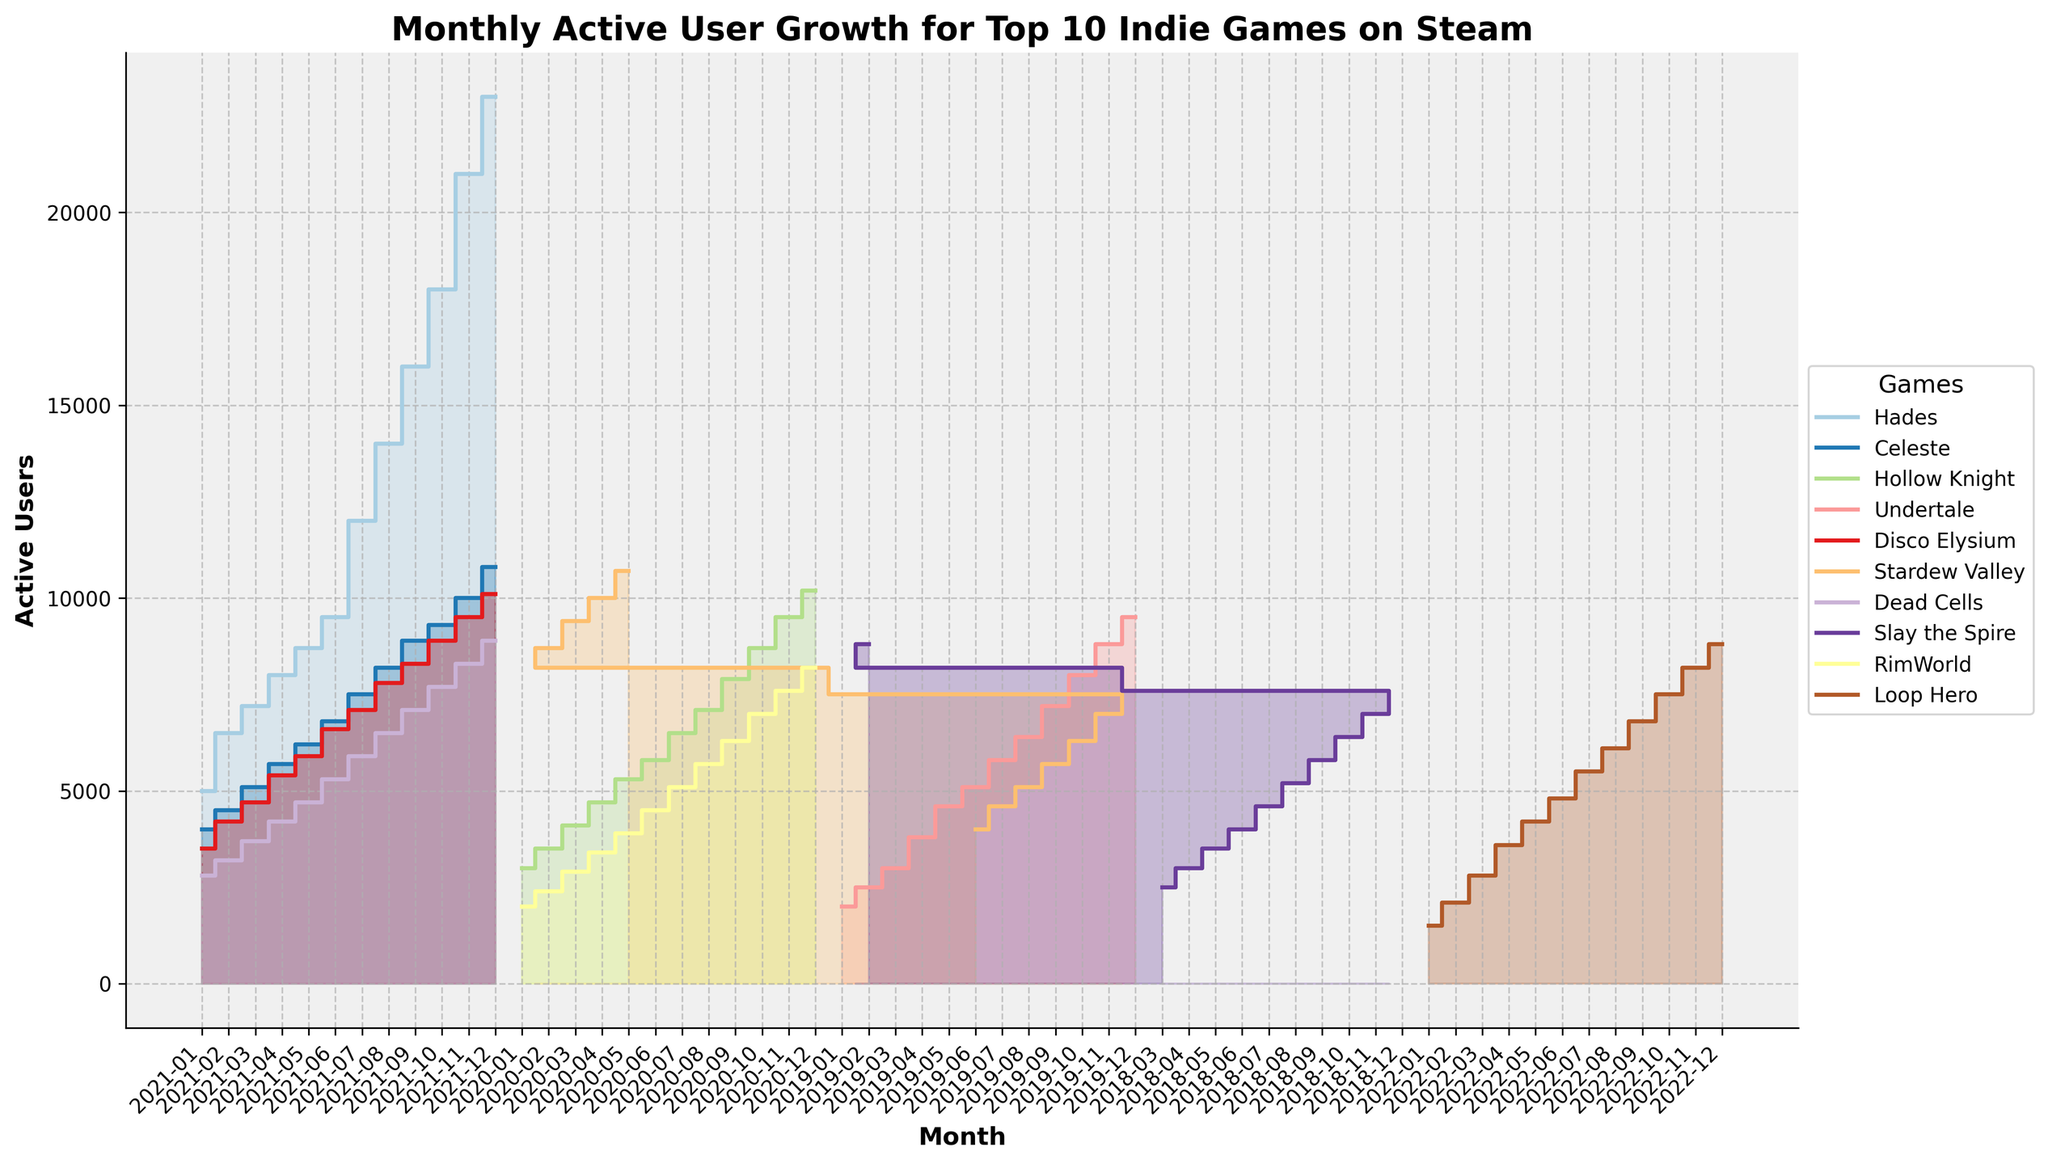which game shows the highest number of active users in December 2021? The chart's legend indicates different lines for each game. By locating December 2021 on the x-axis and following the lines corresponding to the games, we find that Hades has the highest value.
Answer: Hades which game saw the quickest growth in active users from its launch? By evaluating the steepness of the lines stepping upwards from the launch month towards subsequent months, we observe that Hades exhibited a rapid increase in users.
Answer: Hades how does the user growth of Celeste in November 2021 compare to that of Dead Cells? Trace the lines for Celeste and Dead Cells in November 2021 by referring to the legend. Celeste has nearly 10800 users while Dead Cells reaches around 8300 in this month.
Answer: Celeste has higher growth which game shows an overall upward trend without any months of decline? Examine each game's trend line from its starting point to recent months. Games like Hades, Celeste, and Hollow Knight continuously increase without any visible dips.
Answer: Hades, Celeste, Hollow Knight between February and March 2021, which game experienced the highest absolute increase in active users? Check the step heights between February and March 2021 for all games in the plot. Hades jumps from 6500 to 7200 users within this period, showing the highest absolute growth.
Answer: Hades which game had the smallest initial number of users at its launch? Refer to the starting points of each game's line on the x-axis corresponding to their launch dates. Loop Hero starts with 1500 active users, the lowest amount among all listed games.
Answer: Loop Hero how does the user base of Slay the Spire change over the first year since launch? Trace Slay the Spire's line from March 2018 to February 2019. The user base continually increases with gradual steps each month, ending at 8800 users.
Answer: Constant increase to 8800 users what is the approximate range of active user numbers for RimWorld from launch to the present? RimWorld starts at 2000 users around January 2020 and climbs to about 8200 users by December 2020. The range is approximately the difference between these values.
Answer: 2000 to 8200 users does any game display a plateau or stagnation in user growth over multiple months? Look for flat sections in the step area chart where the number of users remains at the same level. None of the games seem to show a consistent plateau, indicating active user growth each month.
Answer: No game shows stagnation in what month does Disco Elysium surpass 5000 active users? Trace Disco Elysium’s line and observe when it passes the 5000 mark. The user count surpasses 5000 in March 2021.
Answer: March 2021 